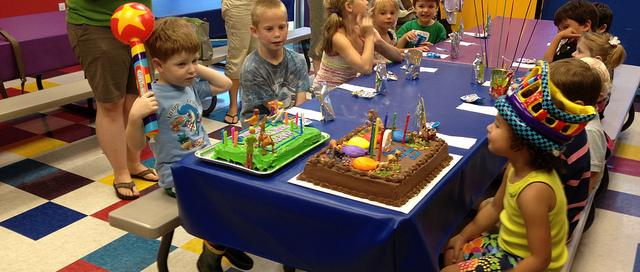What relationship might these two children with the birthday cakes likely have? friends 